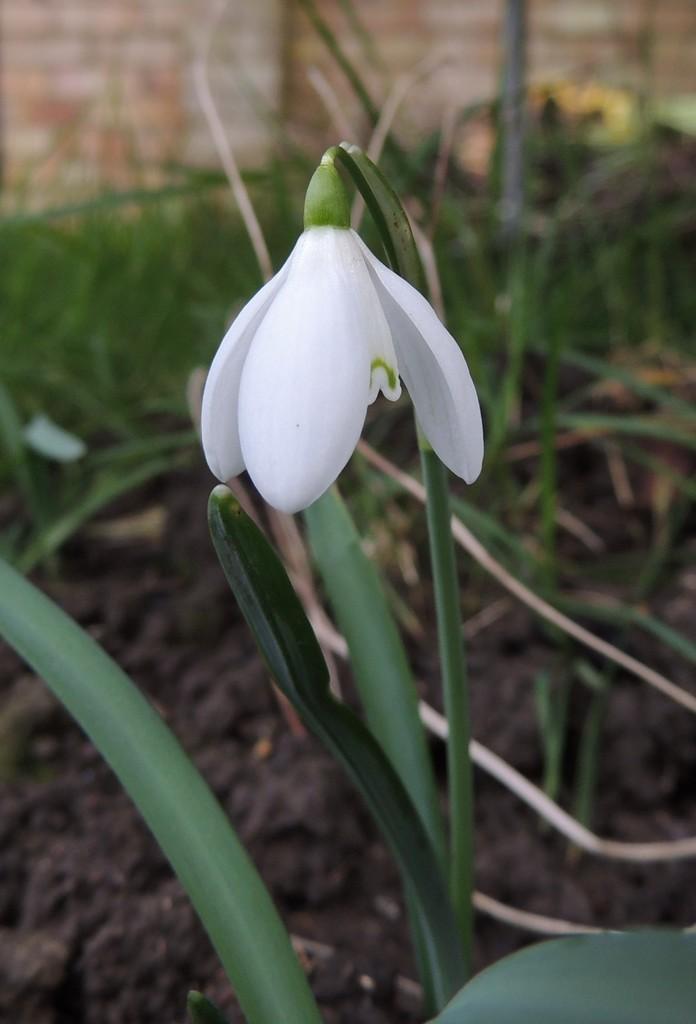Can you describe this image briefly? In this picture I can see a plant with white flower, and in the background there is soil, grass and a wall. 